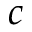Convert formula to latex. <formula><loc_0><loc_0><loc_500><loc_500>c</formula> 